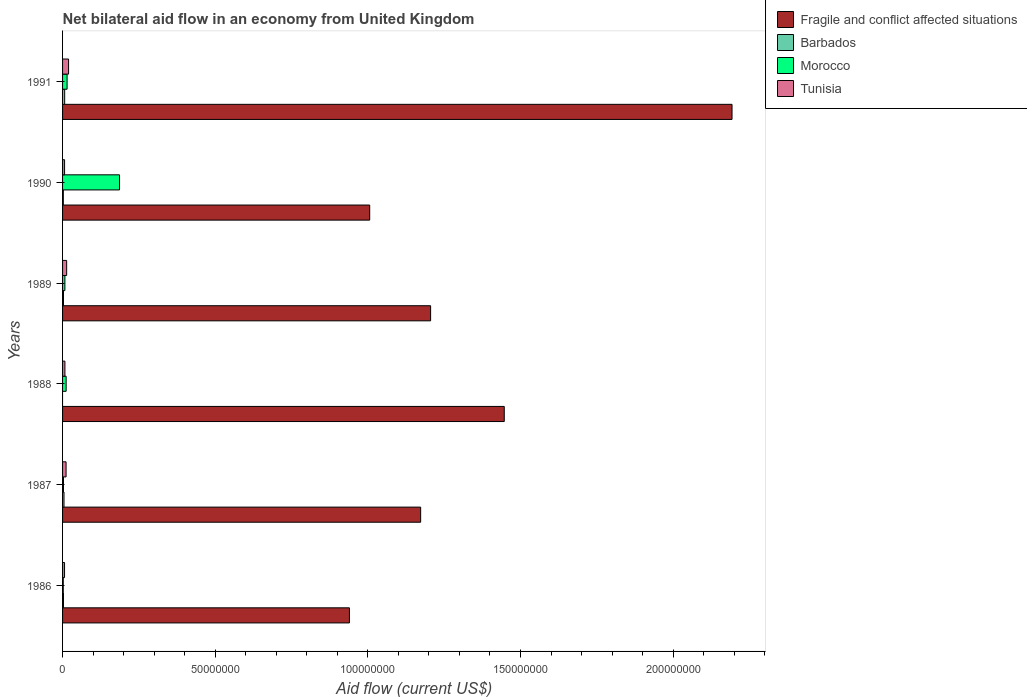How many different coloured bars are there?
Offer a terse response. 4. Are the number of bars per tick equal to the number of legend labels?
Offer a terse response. No. Are the number of bars on each tick of the Y-axis equal?
Ensure brevity in your answer.  No. In how many cases, is the number of bars for a given year not equal to the number of legend labels?
Offer a terse response. 1. What is the net bilateral aid flow in Tunisia in 1991?
Give a very brief answer. 1.97e+06. Across all years, what is the maximum net bilateral aid flow in Morocco?
Ensure brevity in your answer.  1.87e+07. Across all years, what is the minimum net bilateral aid flow in Tunisia?
Make the answer very short. 6.50e+05. In which year was the net bilateral aid flow in Morocco maximum?
Offer a very short reply. 1990. What is the total net bilateral aid flow in Fragile and conflict affected situations in the graph?
Your response must be concise. 7.96e+08. What is the difference between the net bilateral aid flow in Morocco in 1988 and that in 1989?
Provide a short and direct response. 4.10e+05. What is the difference between the net bilateral aid flow in Fragile and conflict affected situations in 1990 and the net bilateral aid flow in Tunisia in 1991?
Ensure brevity in your answer.  9.86e+07. What is the average net bilateral aid flow in Barbados per year?
Provide a short and direct response. 3.35e+05. In the year 1990, what is the difference between the net bilateral aid flow in Morocco and net bilateral aid flow in Barbados?
Make the answer very short. 1.84e+07. What is the ratio of the net bilateral aid flow in Barbados in 1987 to that in 1990?
Ensure brevity in your answer.  1.88. Is the difference between the net bilateral aid flow in Morocco in 1987 and 1990 greater than the difference between the net bilateral aid flow in Barbados in 1987 and 1990?
Offer a terse response. No. What is the difference between the highest and the second highest net bilateral aid flow in Fragile and conflict affected situations?
Your answer should be very brief. 7.46e+07. What is the difference between the highest and the lowest net bilateral aid flow in Morocco?
Your answer should be very brief. 1.84e+07. Is it the case that in every year, the sum of the net bilateral aid flow in Tunisia and net bilateral aid flow in Morocco is greater than the net bilateral aid flow in Barbados?
Ensure brevity in your answer.  Yes. Are all the bars in the graph horizontal?
Keep it short and to the point. Yes. How many years are there in the graph?
Provide a succinct answer. 6. Are the values on the major ticks of X-axis written in scientific E-notation?
Provide a short and direct response. No. Does the graph contain any zero values?
Ensure brevity in your answer.  Yes. Does the graph contain grids?
Offer a very short reply. No. How are the legend labels stacked?
Provide a succinct answer. Vertical. What is the title of the graph?
Make the answer very short. Net bilateral aid flow in an economy from United Kingdom. Does "Yemen, Rep." appear as one of the legend labels in the graph?
Your response must be concise. No. What is the label or title of the Y-axis?
Offer a terse response. Years. What is the Aid flow (current US$) in Fragile and conflict affected situations in 1986?
Provide a succinct answer. 9.40e+07. What is the Aid flow (current US$) in Tunisia in 1986?
Make the answer very short. 6.50e+05. What is the Aid flow (current US$) of Fragile and conflict affected situations in 1987?
Make the answer very short. 1.17e+08. What is the Aid flow (current US$) of Morocco in 1987?
Your answer should be very brief. 3.00e+05. What is the Aid flow (current US$) of Tunisia in 1987?
Provide a succinct answer. 1.15e+06. What is the Aid flow (current US$) in Fragile and conflict affected situations in 1988?
Offer a very short reply. 1.45e+08. What is the Aid flow (current US$) of Morocco in 1988?
Make the answer very short. 1.17e+06. What is the Aid flow (current US$) in Tunisia in 1988?
Offer a very short reply. 7.70e+05. What is the Aid flow (current US$) of Fragile and conflict affected situations in 1989?
Your answer should be very brief. 1.21e+08. What is the Aid flow (current US$) of Morocco in 1989?
Your response must be concise. 7.60e+05. What is the Aid flow (current US$) in Tunisia in 1989?
Your answer should be very brief. 1.34e+06. What is the Aid flow (current US$) in Fragile and conflict affected situations in 1990?
Provide a short and direct response. 1.01e+08. What is the Aid flow (current US$) of Morocco in 1990?
Provide a succinct answer. 1.87e+07. What is the Aid flow (current US$) of Tunisia in 1990?
Provide a short and direct response. 6.60e+05. What is the Aid flow (current US$) of Fragile and conflict affected situations in 1991?
Offer a terse response. 2.19e+08. What is the Aid flow (current US$) in Barbados in 1991?
Give a very brief answer. 6.90e+05. What is the Aid flow (current US$) of Morocco in 1991?
Ensure brevity in your answer.  1.48e+06. What is the Aid flow (current US$) in Tunisia in 1991?
Ensure brevity in your answer.  1.97e+06. Across all years, what is the maximum Aid flow (current US$) of Fragile and conflict affected situations?
Keep it short and to the point. 2.19e+08. Across all years, what is the maximum Aid flow (current US$) in Barbados?
Offer a very short reply. 6.90e+05. Across all years, what is the maximum Aid flow (current US$) of Morocco?
Make the answer very short. 1.87e+07. Across all years, what is the maximum Aid flow (current US$) in Tunisia?
Provide a succinct answer. 1.97e+06. Across all years, what is the minimum Aid flow (current US$) of Fragile and conflict affected situations?
Provide a succinct answer. 9.40e+07. Across all years, what is the minimum Aid flow (current US$) of Morocco?
Offer a terse response. 2.30e+05. Across all years, what is the minimum Aid flow (current US$) of Tunisia?
Your response must be concise. 6.50e+05. What is the total Aid flow (current US$) of Fragile and conflict affected situations in the graph?
Give a very brief answer. 7.96e+08. What is the total Aid flow (current US$) of Barbados in the graph?
Offer a very short reply. 2.01e+06. What is the total Aid flow (current US$) in Morocco in the graph?
Keep it short and to the point. 2.26e+07. What is the total Aid flow (current US$) in Tunisia in the graph?
Keep it short and to the point. 6.54e+06. What is the difference between the Aid flow (current US$) in Fragile and conflict affected situations in 1986 and that in 1987?
Your response must be concise. -2.33e+07. What is the difference between the Aid flow (current US$) in Barbados in 1986 and that in 1987?
Keep it short and to the point. -1.70e+05. What is the difference between the Aid flow (current US$) in Tunisia in 1986 and that in 1987?
Provide a succinct answer. -5.00e+05. What is the difference between the Aid flow (current US$) in Fragile and conflict affected situations in 1986 and that in 1988?
Give a very brief answer. -5.07e+07. What is the difference between the Aid flow (current US$) in Morocco in 1986 and that in 1988?
Offer a terse response. -9.40e+05. What is the difference between the Aid flow (current US$) of Tunisia in 1986 and that in 1988?
Your answer should be compact. -1.20e+05. What is the difference between the Aid flow (current US$) of Fragile and conflict affected situations in 1986 and that in 1989?
Keep it short and to the point. -2.66e+07. What is the difference between the Aid flow (current US$) in Morocco in 1986 and that in 1989?
Keep it short and to the point. -5.30e+05. What is the difference between the Aid flow (current US$) in Tunisia in 1986 and that in 1989?
Offer a terse response. -6.90e+05. What is the difference between the Aid flow (current US$) of Fragile and conflict affected situations in 1986 and that in 1990?
Give a very brief answer. -6.64e+06. What is the difference between the Aid flow (current US$) of Barbados in 1986 and that in 1990?
Provide a succinct answer. 5.00e+04. What is the difference between the Aid flow (current US$) in Morocco in 1986 and that in 1990?
Provide a succinct answer. -1.84e+07. What is the difference between the Aid flow (current US$) in Tunisia in 1986 and that in 1990?
Provide a succinct answer. -10000. What is the difference between the Aid flow (current US$) in Fragile and conflict affected situations in 1986 and that in 1991?
Keep it short and to the point. -1.25e+08. What is the difference between the Aid flow (current US$) in Barbados in 1986 and that in 1991?
Offer a very short reply. -3.90e+05. What is the difference between the Aid flow (current US$) in Morocco in 1986 and that in 1991?
Your response must be concise. -1.25e+06. What is the difference between the Aid flow (current US$) of Tunisia in 1986 and that in 1991?
Provide a short and direct response. -1.32e+06. What is the difference between the Aid flow (current US$) of Fragile and conflict affected situations in 1987 and that in 1988?
Provide a succinct answer. -2.74e+07. What is the difference between the Aid flow (current US$) in Morocco in 1987 and that in 1988?
Make the answer very short. -8.70e+05. What is the difference between the Aid flow (current US$) in Fragile and conflict affected situations in 1987 and that in 1989?
Ensure brevity in your answer.  -3.26e+06. What is the difference between the Aid flow (current US$) of Morocco in 1987 and that in 1989?
Ensure brevity in your answer.  -4.60e+05. What is the difference between the Aid flow (current US$) in Fragile and conflict affected situations in 1987 and that in 1990?
Give a very brief answer. 1.67e+07. What is the difference between the Aid flow (current US$) in Morocco in 1987 and that in 1990?
Provide a succinct answer. -1.84e+07. What is the difference between the Aid flow (current US$) in Tunisia in 1987 and that in 1990?
Ensure brevity in your answer.  4.90e+05. What is the difference between the Aid flow (current US$) in Fragile and conflict affected situations in 1987 and that in 1991?
Give a very brief answer. -1.02e+08. What is the difference between the Aid flow (current US$) in Barbados in 1987 and that in 1991?
Provide a succinct answer. -2.20e+05. What is the difference between the Aid flow (current US$) of Morocco in 1987 and that in 1991?
Your response must be concise. -1.18e+06. What is the difference between the Aid flow (current US$) in Tunisia in 1987 and that in 1991?
Provide a succinct answer. -8.20e+05. What is the difference between the Aid flow (current US$) of Fragile and conflict affected situations in 1988 and that in 1989?
Your answer should be very brief. 2.41e+07. What is the difference between the Aid flow (current US$) of Morocco in 1988 and that in 1989?
Offer a very short reply. 4.10e+05. What is the difference between the Aid flow (current US$) of Tunisia in 1988 and that in 1989?
Make the answer very short. -5.70e+05. What is the difference between the Aid flow (current US$) in Fragile and conflict affected situations in 1988 and that in 1990?
Provide a short and direct response. 4.41e+07. What is the difference between the Aid flow (current US$) of Morocco in 1988 and that in 1990?
Offer a terse response. -1.75e+07. What is the difference between the Aid flow (current US$) of Fragile and conflict affected situations in 1988 and that in 1991?
Ensure brevity in your answer.  -7.46e+07. What is the difference between the Aid flow (current US$) in Morocco in 1988 and that in 1991?
Your answer should be very brief. -3.10e+05. What is the difference between the Aid flow (current US$) in Tunisia in 1988 and that in 1991?
Keep it short and to the point. -1.20e+06. What is the difference between the Aid flow (current US$) of Fragile and conflict affected situations in 1989 and that in 1990?
Make the answer very short. 2.00e+07. What is the difference between the Aid flow (current US$) of Morocco in 1989 and that in 1990?
Provide a short and direct response. -1.79e+07. What is the difference between the Aid flow (current US$) of Tunisia in 1989 and that in 1990?
Give a very brief answer. 6.80e+05. What is the difference between the Aid flow (current US$) of Fragile and conflict affected situations in 1989 and that in 1991?
Offer a terse response. -9.87e+07. What is the difference between the Aid flow (current US$) in Barbados in 1989 and that in 1991?
Provide a short and direct response. -3.90e+05. What is the difference between the Aid flow (current US$) of Morocco in 1989 and that in 1991?
Provide a succinct answer. -7.20e+05. What is the difference between the Aid flow (current US$) in Tunisia in 1989 and that in 1991?
Your answer should be very brief. -6.30e+05. What is the difference between the Aid flow (current US$) of Fragile and conflict affected situations in 1990 and that in 1991?
Give a very brief answer. -1.19e+08. What is the difference between the Aid flow (current US$) of Barbados in 1990 and that in 1991?
Make the answer very short. -4.40e+05. What is the difference between the Aid flow (current US$) of Morocco in 1990 and that in 1991?
Your answer should be compact. 1.72e+07. What is the difference between the Aid flow (current US$) in Tunisia in 1990 and that in 1991?
Your answer should be compact. -1.31e+06. What is the difference between the Aid flow (current US$) in Fragile and conflict affected situations in 1986 and the Aid flow (current US$) in Barbados in 1987?
Your response must be concise. 9.35e+07. What is the difference between the Aid flow (current US$) of Fragile and conflict affected situations in 1986 and the Aid flow (current US$) of Morocco in 1987?
Ensure brevity in your answer.  9.37e+07. What is the difference between the Aid flow (current US$) in Fragile and conflict affected situations in 1986 and the Aid flow (current US$) in Tunisia in 1987?
Offer a very short reply. 9.28e+07. What is the difference between the Aid flow (current US$) in Barbados in 1986 and the Aid flow (current US$) in Tunisia in 1987?
Offer a terse response. -8.50e+05. What is the difference between the Aid flow (current US$) in Morocco in 1986 and the Aid flow (current US$) in Tunisia in 1987?
Provide a short and direct response. -9.20e+05. What is the difference between the Aid flow (current US$) of Fragile and conflict affected situations in 1986 and the Aid flow (current US$) of Morocco in 1988?
Offer a terse response. 9.28e+07. What is the difference between the Aid flow (current US$) of Fragile and conflict affected situations in 1986 and the Aid flow (current US$) of Tunisia in 1988?
Give a very brief answer. 9.32e+07. What is the difference between the Aid flow (current US$) in Barbados in 1986 and the Aid flow (current US$) in Morocco in 1988?
Ensure brevity in your answer.  -8.70e+05. What is the difference between the Aid flow (current US$) of Barbados in 1986 and the Aid flow (current US$) of Tunisia in 1988?
Give a very brief answer. -4.70e+05. What is the difference between the Aid flow (current US$) in Morocco in 1986 and the Aid flow (current US$) in Tunisia in 1988?
Make the answer very short. -5.40e+05. What is the difference between the Aid flow (current US$) of Fragile and conflict affected situations in 1986 and the Aid flow (current US$) of Barbados in 1989?
Ensure brevity in your answer.  9.37e+07. What is the difference between the Aid flow (current US$) of Fragile and conflict affected situations in 1986 and the Aid flow (current US$) of Morocco in 1989?
Make the answer very short. 9.32e+07. What is the difference between the Aid flow (current US$) in Fragile and conflict affected situations in 1986 and the Aid flow (current US$) in Tunisia in 1989?
Ensure brevity in your answer.  9.26e+07. What is the difference between the Aid flow (current US$) of Barbados in 1986 and the Aid flow (current US$) of Morocco in 1989?
Give a very brief answer. -4.60e+05. What is the difference between the Aid flow (current US$) of Barbados in 1986 and the Aid flow (current US$) of Tunisia in 1989?
Offer a very short reply. -1.04e+06. What is the difference between the Aid flow (current US$) in Morocco in 1986 and the Aid flow (current US$) in Tunisia in 1989?
Give a very brief answer. -1.11e+06. What is the difference between the Aid flow (current US$) of Fragile and conflict affected situations in 1986 and the Aid flow (current US$) of Barbados in 1990?
Ensure brevity in your answer.  9.37e+07. What is the difference between the Aid flow (current US$) of Fragile and conflict affected situations in 1986 and the Aid flow (current US$) of Morocco in 1990?
Your answer should be very brief. 7.53e+07. What is the difference between the Aid flow (current US$) of Fragile and conflict affected situations in 1986 and the Aid flow (current US$) of Tunisia in 1990?
Ensure brevity in your answer.  9.33e+07. What is the difference between the Aid flow (current US$) of Barbados in 1986 and the Aid flow (current US$) of Morocco in 1990?
Offer a terse response. -1.84e+07. What is the difference between the Aid flow (current US$) in Barbados in 1986 and the Aid flow (current US$) in Tunisia in 1990?
Provide a short and direct response. -3.60e+05. What is the difference between the Aid flow (current US$) in Morocco in 1986 and the Aid flow (current US$) in Tunisia in 1990?
Your answer should be compact. -4.30e+05. What is the difference between the Aid flow (current US$) of Fragile and conflict affected situations in 1986 and the Aid flow (current US$) of Barbados in 1991?
Ensure brevity in your answer.  9.33e+07. What is the difference between the Aid flow (current US$) in Fragile and conflict affected situations in 1986 and the Aid flow (current US$) in Morocco in 1991?
Make the answer very short. 9.25e+07. What is the difference between the Aid flow (current US$) in Fragile and conflict affected situations in 1986 and the Aid flow (current US$) in Tunisia in 1991?
Keep it short and to the point. 9.20e+07. What is the difference between the Aid flow (current US$) in Barbados in 1986 and the Aid flow (current US$) in Morocco in 1991?
Ensure brevity in your answer.  -1.18e+06. What is the difference between the Aid flow (current US$) of Barbados in 1986 and the Aid flow (current US$) of Tunisia in 1991?
Offer a terse response. -1.67e+06. What is the difference between the Aid flow (current US$) of Morocco in 1986 and the Aid flow (current US$) of Tunisia in 1991?
Your answer should be compact. -1.74e+06. What is the difference between the Aid flow (current US$) in Fragile and conflict affected situations in 1987 and the Aid flow (current US$) in Morocco in 1988?
Keep it short and to the point. 1.16e+08. What is the difference between the Aid flow (current US$) in Fragile and conflict affected situations in 1987 and the Aid flow (current US$) in Tunisia in 1988?
Keep it short and to the point. 1.17e+08. What is the difference between the Aid flow (current US$) of Barbados in 1987 and the Aid flow (current US$) of Morocco in 1988?
Provide a short and direct response. -7.00e+05. What is the difference between the Aid flow (current US$) of Morocco in 1987 and the Aid flow (current US$) of Tunisia in 1988?
Your response must be concise. -4.70e+05. What is the difference between the Aid flow (current US$) in Fragile and conflict affected situations in 1987 and the Aid flow (current US$) in Barbados in 1989?
Give a very brief answer. 1.17e+08. What is the difference between the Aid flow (current US$) in Fragile and conflict affected situations in 1987 and the Aid flow (current US$) in Morocco in 1989?
Your answer should be compact. 1.17e+08. What is the difference between the Aid flow (current US$) of Fragile and conflict affected situations in 1987 and the Aid flow (current US$) of Tunisia in 1989?
Your response must be concise. 1.16e+08. What is the difference between the Aid flow (current US$) in Barbados in 1987 and the Aid flow (current US$) in Morocco in 1989?
Provide a short and direct response. -2.90e+05. What is the difference between the Aid flow (current US$) of Barbados in 1987 and the Aid flow (current US$) of Tunisia in 1989?
Your answer should be very brief. -8.70e+05. What is the difference between the Aid flow (current US$) of Morocco in 1987 and the Aid flow (current US$) of Tunisia in 1989?
Keep it short and to the point. -1.04e+06. What is the difference between the Aid flow (current US$) in Fragile and conflict affected situations in 1987 and the Aid flow (current US$) in Barbados in 1990?
Make the answer very short. 1.17e+08. What is the difference between the Aid flow (current US$) of Fragile and conflict affected situations in 1987 and the Aid flow (current US$) of Morocco in 1990?
Give a very brief answer. 9.86e+07. What is the difference between the Aid flow (current US$) in Fragile and conflict affected situations in 1987 and the Aid flow (current US$) in Tunisia in 1990?
Offer a very short reply. 1.17e+08. What is the difference between the Aid flow (current US$) in Barbados in 1987 and the Aid flow (current US$) in Morocco in 1990?
Provide a short and direct response. -1.82e+07. What is the difference between the Aid flow (current US$) in Barbados in 1987 and the Aid flow (current US$) in Tunisia in 1990?
Offer a very short reply. -1.90e+05. What is the difference between the Aid flow (current US$) of Morocco in 1987 and the Aid flow (current US$) of Tunisia in 1990?
Provide a short and direct response. -3.60e+05. What is the difference between the Aid flow (current US$) in Fragile and conflict affected situations in 1987 and the Aid flow (current US$) in Barbados in 1991?
Provide a succinct answer. 1.17e+08. What is the difference between the Aid flow (current US$) of Fragile and conflict affected situations in 1987 and the Aid flow (current US$) of Morocco in 1991?
Give a very brief answer. 1.16e+08. What is the difference between the Aid flow (current US$) in Fragile and conflict affected situations in 1987 and the Aid flow (current US$) in Tunisia in 1991?
Offer a very short reply. 1.15e+08. What is the difference between the Aid flow (current US$) of Barbados in 1987 and the Aid flow (current US$) of Morocco in 1991?
Provide a succinct answer. -1.01e+06. What is the difference between the Aid flow (current US$) in Barbados in 1987 and the Aid flow (current US$) in Tunisia in 1991?
Your answer should be very brief. -1.50e+06. What is the difference between the Aid flow (current US$) in Morocco in 1987 and the Aid flow (current US$) in Tunisia in 1991?
Provide a short and direct response. -1.67e+06. What is the difference between the Aid flow (current US$) of Fragile and conflict affected situations in 1988 and the Aid flow (current US$) of Barbados in 1989?
Offer a terse response. 1.44e+08. What is the difference between the Aid flow (current US$) in Fragile and conflict affected situations in 1988 and the Aid flow (current US$) in Morocco in 1989?
Provide a succinct answer. 1.44e+08. What is the difference between the Aid flow (current US$) of Fragile and conflict affected situations in 1988 and the Aid flow (current US$) of Tunisia in 1989?
Make the answer very short. 1.43e+08. What is the difference between the Aid flow (current US$) of Morocco in 1988 and the Aid flow (current US$) of Tunisia in 1989?
Give a very brief answer. -1.70e+05. What is the difference between the Aid flow (current US$) in Fragile and conflict affected situations in 1988 and the Aid flow (current US$) in Barbados in 1990?
Your response must be concise. 1.44e+08. What is the difference between the Aid flow (current US$) of Fragile and conflict affected situations in 1988 and the Aid flow (current US$) of Morocco in 1990?
Your answer should be very brief. 1.26e+08. What is the difference between the Aid flow (current US$) of Fragile and conflict affected situations in 1988 and the Aid flow (current US$) of Tunisia in 1990?
Provide a short and direct response. 1.44e+08. What is the difference between the Aid flow (current US$) in Morocco in 1988 and the Aid flow (current US$) in Tunisia in 1990?
Offer a very short reply. 5.10e+05. What is the difference between the Aid flow (current US$) in Fragile and conflict affected situations in 1988 and the Aid flow (current US$) in Barbados in 1991?
Offer a terse response. 1.44e+08. What is the difference between the Aid flow (current US$) of Fragile and conflict affected situations in 1988 and the Aid flow (current US$) of Morocco in 1991?
Ensure brevity in your answer.  1.43e+08. What is the difference between the Aid flow (current US$) in Fragile and conflict affected situations in 1988 and the Aid flow (current US$) in Tunisia in 1991?
Offer a very short reply. 1.43e+08. What is the difference between the Aid flow (current US$) in Morocco in 1988 and the Aid flow (current US$) in Tunisia in 1991?
Provide a short and direct response. -8.00e+05. What is the difference between the Aid flow (current US$) of Fragile and conflict affected situations in 1989 and the Aid flow (current US$) of Barbados in 1990?
Offer a very short reply. 1.20e+08. What is the difference between the Aid flow (current US$) in Fragile and conflict affected situations in 1989 and the Aid flow (current US$) in Morocco in 1990?
Ensure brevity in your answer.  1.02e+08. What is the difference between the Aid flow (current US$) of Fragile and conflict affected situations in 1989 and the Aid flow (current US$) of Tunisia in 1990?
Ensure brevity in your answer.  1.20e+08. What is the difference between the Aid flow (current US$) of Barbados in 1989 and the Aid flow (current US$) of Morocco in 1990?
Provide a short and direct response. -1.84e+07. What is the difference between the Aid flow (current US$) in Barbados in 1989 and the Aid flow (current US$) in Tunisia in 1990?
Make the answer very short. -3.60e+05. What is the difference between the Aid flow (current US$) in Morocco in 1989 and the Aid flow (current US$) in Tunisia in 1990?
Your answer should be very brief. 1.00e+05. What is the difference between the Aid flow (current US$) of Fragile and conflict affected situations in 1989 and the Aid flow (current US$) of Barbados in 1991?
Provide a short and direct response. 1.20e+08. What is the difference between the Aid flow (current US$) of Fragile and conflict affected situations in 1989 and the Aid flow (current US$) of Morocco in 1991?
Your response must be concise. 1.19e+08. What is the difference between the Aid flow (current US$) in Fragile and conflict affected situations in 1989 and the Aid flow (current US$) in Tunisia in 1991?
Keep it short and to the point. 1.19e+08. What is the difference between the Aid flow (current US$) in Barbados in 1989 and the Aid flow (current US$) in Morocco in 1991?
Ensure brevity in your answer.  -1.18e+06. What is the difference between the Aid flow (current US$) of Barbados in 1989 and the Aid flow (current US$) of Tunisia in 1991?
Ensure brevity in your answer.  -1.67e+06. What is the difference between the Aid flow (current US$) in Morocco in 1989 and the Aid flow (current US$) in Tunisia in 1991?
Your response must be concise. -1.21e+06. What is the difference between the Aid flow (current US$) in Fragile and conflict affected situations in 1990 and the Aid flow (current US$) in Barbados in 1991?
Your response must be concise. 9.99e+07. What is the difference between the Aid flow (current US$) of Fragile and conflict affected situations in 1990 and the Aid flow (current US$) of Morocco in 1991?
Offer a terse response. 9.91e+07. What is the difference between the Aid flow (current US$) in Fragile and conflict affected situations in 1990 and the Aid flow (current US$) in Tunisia in 1991?
Keep it short and to the point. 9.86e+07. What is the difference between the Aid flow (current US$) in Barbados in 1990 and the Aid flow (current US$) in Morocco in 1991?
Your answer should be compact. -1.23e+06. What is the difference between the Aid flow (current US$) in Barbados in 1990 and the Aid flow (current US$) in Tunisia in 1991?
Offer a very short reply. -1.72e+06. What is the difference between the Aid flow (current US$) of Morocco in 1990 and the Aid flow (current US$) of Tunisia in 1991?
Your response must be concise. 1.67e+07. What is the average Aid flow (current US$) of Fragile and conflict affected situations per year?
Your answer should be compact. 1.33e+08. What is the average Aid flow (current US$) of Barbados per year?
Your answer should be very brief. 3.35e+05. What is the average Aid flow (current US$) of Morocco per year?
Give a very brief answer. 3.77e+06. What is the average Aid flow (current US$) in Tunisia per year?
Your answer should be very brief. 1.09e+06. In the year 1986, what is the difference between the Aid flow (current US$) of Fragile and conflict affected situations and Aid flow (current US$) of Barbados?
Offer a very short reply. 9.37e+07. In the year 1986, what is the difference between the Aid flow (current US$) of Fragile and conflict affected situations and Aid flow (current US$) of Morocco?
Your response must be concise. 9.37e+07. In the year 1986, what is the difference between the Aid flow (current US$) in Fragile and conflict affected situations and Aid flow (current US$) in Tunisia?
Keep it short and to the point. 9.33e+07. In the year 1986, what is the difference between the Aid flow (current US$) in Barbados and Aid flow (current US$) in Morocco?
Your answer should be very brief. 7.00e+04. In the year 1986, what is the difference between the Aid flow (current US$) of Barbados and Aid flow (current US$) of Tunisia?
Your answer should be very brief. -3.50e+05. In the year 1986, what is the difference between the Aid flow (current US$) of Morocco and Aid flow (current US$) of Tunisia?
Make the answer very short. -4.20e+05. In the year 1987, what is the difference between the Aid flow (current US$) in Fragile and conflict affected situations and Aid flow (current US$) in Barbados?
Give a very brief answer. 1.17e+08. In the year 1987, what is the difference between the Aid flow (current US$) in Fragile and conflict affected situations and Aid flow (current US$) in Morocco?
Ensure brevity in your answer.  1.17e+08. In the year 1987, what is the difference between the Aid flow (current US$) in Fragile and conflict affected situations and Aid flow (current US$) in Tunisia?
Ensure brevity in your answer.  1.16e+08. In the year 1987, what is the difference between the Aid flow (current US$) of Barbados and Aid flow (current US$) of Morocco?
Offer a very short reply. 1.70e+05. In the year 1987, what is the difference between the Aid flow (current US$) in Barbados and Aid flow (current US$) in Tunisia?
Offer a terse response. -6.80e+05. In the year 1987, what is the difference between the Aid flow (current US$) in Morocco and Aid flow (current US$) in Tunisia?
Offer a very short reply. -8.50e+05. In the year 1988, what is the difference between the Aid flow (current US$) in Fragile and conflict affected situations and Aid flow (current US$) in Morocco?
Ensure brevity in your answer.  1.44e+08. In the year 1988, what is the difference between the Aid flow (current US$) in Fragile and conflict affected situations and Aid flow (current US$) in Tunisia?
Offer a very short reply. 1.44e+08. In the year 1988, what is the difference between the Aid flow (current US$) in Morocco and Aid flow (current US$) in Tunisia?
Ensure brevity in your answer.  4.00e+05. In the year 1989, what is the difference between the Aid flow (current US$) of Fragile and conflict affected situations and Aid flow (current US$) of Barbados?
Keep it short and to the point. 1.20e+08. In the year 1989, what is the difference between the Aid flow (current US$) in Fragile and conflict affected situations and Aid flow (current US$) in Morocco?
Offer a very short reply. 1.20e+08. In the year 1989, what is the difference between the Aid flow (current US$) in Fragile and conflict affected situations and Aid flow (current US$) in Tunisia?
Provide a succinct answer. 1.19e+08. In the year 1989, what is the difference between the Aid flow (current US$) of Barbados and Aid flow (current US$) of Morocco?
Your answer should be very brief. -4.60e+05. In the year 1989, what is the difference between the Aid flow (current US$) of Barbados and Aid flow (current US$) of Tunisia?
Provide a succinct answer. -1.04e+06. In the year 1989, what is the difference between the Aid flow (current US$) in Morocco and Aid flow (current US$) in Tunisia?
Your answer should be compact. -5.80e+05. In the year 1990, what is the difference between the Aid flow (current US$) of Fragile and conflict affected situations and Aid flow (current US$) of Barbados?
Your response must be concise. 1.00e+08. In the year 1990, what is the difference between the Aid flow (current US$) of Fragile and conflict affected situations and Aid flow (current US$) of Morocco?
Ensure brevity in your answer.  8.20e+07. In the year 1990, what is the difference between the Aid flow (current US$) in Fragile and conflict affected situations and Aid flow (current US$) in Tunisia?
Offer a terse response. 1.00e+08. In the year 1990, what is the difference between the Aid flow (current US$) of Barbados and Aid flow (current US$) of Morocco?
Offer a very short reply. -1.84e+07. In the year 1990, what is the difference between the Aid flow (current US$) of Barbados and Aid flow (current US$) of Tunisia?
Offer a very short reply. -4.10e+05. In the year 1990, what is the difference between the Aid flow (current US$) of Morocco and Aid flow (current US$) of Tunisia?
Keep it short and to the point. 1.80e+07. In the year 1991, what is the difference between the Aid flow (current US$) of Fragile and conflict affected situations and Aid flow (current US$) of Barbados?
Provide a short and direct response. 2.19e+08. In the year 1991, what is the difference between the Aid flow (current US$) in Fragile and conflict affected situations and Aid flow (current US$) in Morocco?
Give a very brief answer. 2.18e+08. In the year 1991, what is the difference between the Aid flow (current US$) of Fragile and conflict affected situations and Aid flow (current US$) of Tunisia?
Provide a short and direct response. 2.17e+08. In the year 1991, what is the difference between the Aid flow (current US$) in Barbados and Aid flow (current US$) in Morocco?
Keep it short and to the point. -7.90e+05. In the year 1991, what is the difference between the Aid flow (current US$) in Barbados and Aid flow (current US$) in Tunisia?
Give a very brief answer. -1.28e+06. In the year 1991, what is the difference between the Aid flow (current US$) of Morocco and Aid flow (current US$) of Tunisia?
Provide a succinct answer. -4.90e+05. What is the ratio of the Aid flow (current US$) of Fragile and conflict affected situations in 1986 to that in 1987?
Make the answer very short. 0.8. What is the ratio of the Aid flow (current US$) of Barbados in 1986 to that in 1987?
Offer a terse response. 0.64. What is the ratio of the Aid flow (current US$) of Morocco in 1986 to that in 1987?
Your answer should be compact. 0.77. What is the ratio of the Aid flow (current US$) in Tunisia in 1986 to that in 1987?
Your answer should be very brief. 0.57. What is the ratio of the Aid flow (current US$) of Fragile and conflict affected situations in 1986 to that in 1988?
Your response must be concise. 0.65. What is the ratio of the Aid flow (current US$) in Morocco in 1986 to that in 1988?
Provide a succinct answer. 0.2. What is the ratio of the Aid flow (current US$) in Tunisia in 1986 to that in 1988?
Your answer should be very brief. 0.84. What is the ratio of the Aid flow (current US$) of Fragile and conflict affected situations in 1986 to that in 1989?
Make the answer very short. 0.78. What is the ratio of the Aid flow (current US$) in Barbados in 1986 to that in 1989?
Provide a succinct answer. 1. What is the ratio of the Aid flow (current US$) in Morocco in 1986 to that in 1989?
Give a very brief answer. 0.3. What is the ratio of the Aid flow (current US$) in Tunisia in 1986 to that in 1989?
Ensure brevity in your answer.  0.49. What is the ratio of the Aid flow (current US$) of Fragile and conflict affected situations in 1986 to that in 1990?
Keep it short and to the point. 0.93. What is the ratio of the Aid flow (current US$) in Barbados in 1986 to that in 1990?
Ensure brevity in your answer.  1.2. What is the ratio of the Aid flow (current US$) of Morocco in 1986 to that in 1990?
Provide a short and direct response. 0.01. What is the ratio of the Aid flow (current US$) in Fragile and conflict affected situations in 1986 to that in 1991?
Offer a terse response. 0.43. What is the ratio of the Aid flow (current US$) of Barbados in 1986 to that in 1991?
Your answer should be very brief. 0.43. What is the ratio of the Aid flow (current US$) in Morocco in 1986 to that in 1991?
Give a very brief answer. 0.16. What is the ratio of the Aid flow (current US$) of Tunisia in 1986 to that in 1991?
Make the answer very short. 0.33. What is the ratio of the Aid flow (current US$) in Fragile and conflict affected situations in 1987 to that in 1988?
Keep it short and to the point. 0.81. What is the ratio of the Aid flow (current US$) in Morocco in 1987 to that in 1988?
Give a very brief answer. 0.26. What is the ratio of the Aid flow (current US$) of Tunisia in 1987 to that in 1988?
Offer a terse response. 1.49. What is the ratio of the Aid flow (current US$) in Barbados in 1987 to that in 1989?
Offer a very short reply. 1.57. What is the ratio of the Aid flow (current US$) in Morocco in 1987 to that in 1989?
Make the answer very short. 0.39. What is the ratio of the Aid flow (current US$) of Tunisia in 1987 to that in 1989?
Keep it short and to the point. 0.86. What is the ratio of the Aid flow (current US$) of Fragile and conflict affected situations in 1987 to that in 1990?
Give a very brief answer. 1.17. What is the ratio of the Aid flow (current US$) of Barbados in 1987 to that in 1990?
Your answer should be very brief. 1.88. What is the ratio of the Aid flow (current US$) in Morocco in 1987 to that in 1990?
Your answer should be compact. 0.02. What is the ratio of the Aid flow (current US$) of Tunisia in 1987 to that in 1990?
Keep it short and to the point. 1.74. What is the ratio of the Aid flow (current US$) in Fragile and conflict affected situations in 1987 to that in 1991?
Provide a succinct answer. 0.53. What is the ratio of the Aid flow (current US$) in Barbados in 1987 to that in 1991?
Give a very brief answer. 0.68. What is the ratio of the Aid flow (current US$) of Morocco in 1987 to that in 1991?
Your answer should be compact. 0.2. What is the ratio of the Aid flow (current US$) of Tunisia in 1987 to that in 1991?
Keep it short and to the point. 0.58. What is the ratio of the Aid flow (current US$) of Fragile and conflict affected situations in 1988 to that in 1989?
Your response must be concise. 1.2. What is the ratio of the Aid flow (current US$) in Morocco in 1988 to that in 1989?
Your answer should be compact. 1.54. What is the ratio of the Aid flow (current US$) in Tunisia in 1988 to that in 1989?
Your response must be concise. 0.57. What is the ratio of the Aid flow (current US$) in Fragile and conflict affected situations in 1988 to that in 1990?
Ensure brevity in your answer.  1.44. What is the ratio of the Aid flow (current US$) of Morocco in 1988 to that in 1990?
Your response must be concise. 0.06. What is the ratio of the Aid flow (current US$) in Fragile and conflict affected situations in 1988 to that in 1991?
Offer a terse response. 0.66. What is the ratio of the Aid flow (current US$) of Morocco in 1988 to that in 1991?
Make the answer very short. 0.79. What is the ratio of the Aid flow (current US$) of Tunisia in 1988 to that in 1991?
Keep it short and to the point. 0.39. What is the ratio of the Aid flow (current US$) in Fragile and conflict affected situations in 1989 to that in 1990?
Give a very brief answer. 1.2. What is the ratio of the Aid flow (current US$) of Barbados in 1989 to that in 1990?
Your response must be concise. 1.2. What is the ratio of the Aid flow (current US$) of Morocco in 1989 to that in 1990?
Your response must be concise. 0.04. What is the ratio of the Aid flow (current US$) of Tunisia in 1989 to that in 1990?
Ensure brevity in your answer.  2.03. What is the ratio of the Aid flow (current US$) in Fragile and conflict affected situations in 1989 to that in 1991?
Provide a succinct answer. 0.55. What is the ratio of the Aid flow (current US$) of Barbados in 1989 to that in 1991?
Your answer should be compact. 0.43. What is the ratio of the Aid flow (current US$) of Morocco in 1989 to that in 1991?
Your response must be concise. 0.51. What is the ratio of the Aid flow (current US$) of Tunisia in 1989 to that in 1991?
Give a very brief answer. 0.68. What is the ratio of the Aid flow (current US$) of Fragile and conflict affected situations in 1990 to that in 1991?
Make the answer very short. 0.46. What is the ratio of the Aid flow (current US$) of Barbados in 1990 to that in 1991?
Give a very brief answer. 0.36. What is the ratio of the Aid flow (current US$) of Morocco in 1990 to that in 1991?
Offer a very short reply. 12.61. What is the ratio of the Aid flow (current US$) of Tunisia in 1990 to that in 1991?
Give a very brief answer. 0.34. What is the difference between the highest and the second highest Aid flow (current US$) in Fragile and conflict affected situations?
Your answer should be very brief. 7.46e+07. What is the difference between the highest and the second highest Aid flow (current US$) of Morocco?
Ensure brevity in your answer.  1.72e+07. What is the difference between the highest and the second highest Aid flow (current US$) of Tunisia?
Ensure brevity in your answer.  6.30e+05. What is the difference between the highest and the lowest Aid flow (current US$) in Fragile and conflict affected situations?
Offer a terse response. 1.25e+08. What is the difference between the highest and the lowest Aid flow (current US$) in Barbados?
Make the answer very short. 6.90e+05. What is the difference between the highest and the lowest Aid flow (current US$) in Morocco?
Give a very brief answer. 1.84e+07. What is the difference between the highest and the lowest Aid flow (current US$) in Tunisia?
Provide a succinct answer. 1.32e+06. 